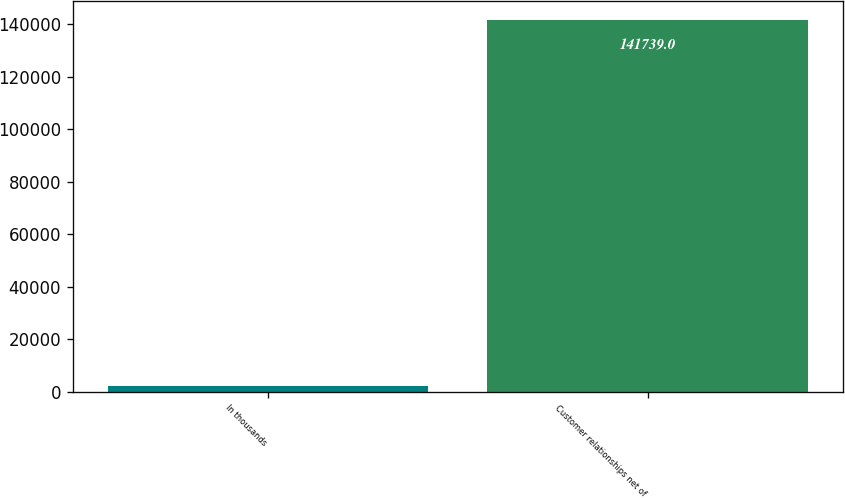<chart> <loc_0><loc_0><loc_500><loc_500><bar_chart><fcel>In thousands<fcel>Customer relationships net of<nl><fcel>2008<fcel>141739<nl></chart> 